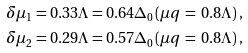Convert formula to latex. <formula><loc_0><loc_0><loc_500><loc_500>\delta \mu _ { 1 } & = 0 . 3 3 \Lambda = 0 . 6 4 \Delta _ { 0 } ( \mu q \, = \, 0 . 8 \Lambda ) \, , \\ \delta \mu _ { 2 } & = 0 . 2 9 \Lambda = 0 . 5 7 \Delta _ { 0 } ( \mu q \, = \, 0 . 8 \Lambda ) \, ,</formula> 